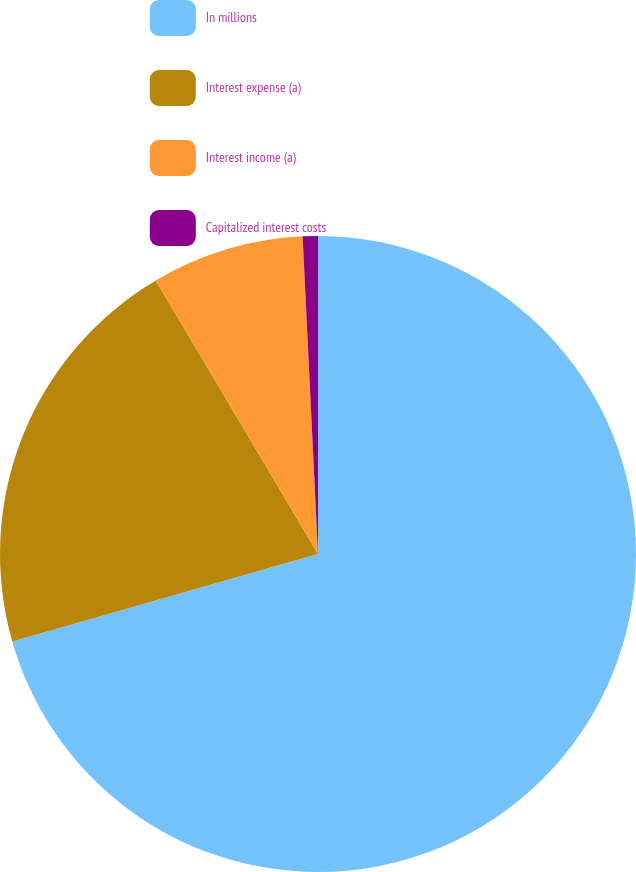<chart> <loc_0><loc_0><loc_500><loc_500><pie_chart><fcel>In millions<fcel>Interest expense (a)<fcel>Interest income (a)<fcel>Capitalized interest costs<nl><fcel>70.56%<fcel>20.91%<fcel>7.75%<fcel>0.77%<nl></chart> 